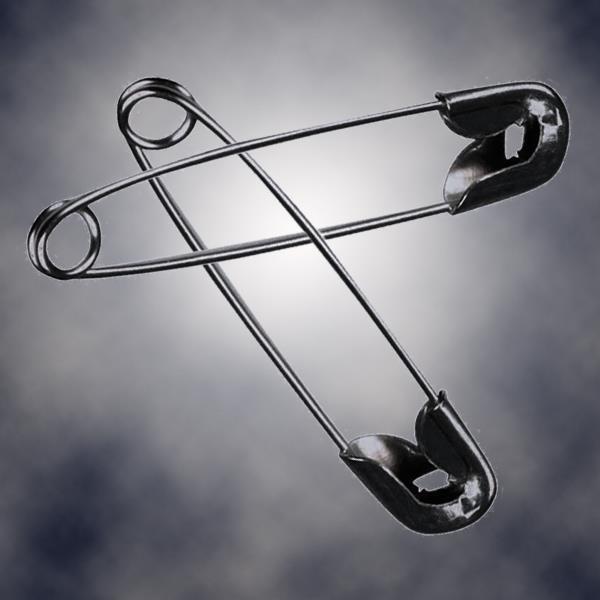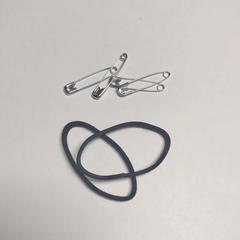The first image is the image on the left, the second image is the image on the right. Considering the images on both sides, is "An image contains exactly two safety pins, displayed one above the other, and not overlapping." valid? Answer yes or no. No. The first image is the image on the left, the second image is the image on the right. Examine the images to the left and right. Is the description "The two pins in the image on the left are not touching each other." accurate? Answer yes or no. No. 